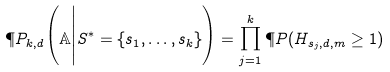<formula> <loc_0><loc_0><loc_500><loc_500>\P P _ { k , d } \Big ( { \mathbb { A } } \Big | S ^ { * } = \{ s _ { 1 } , \dots , s _ { k } \} \Big ) = \prod _ { j = 1 } ^ { k } \P P ( H _ { s _ { j } , d , m } \geq 1 )</formula> 